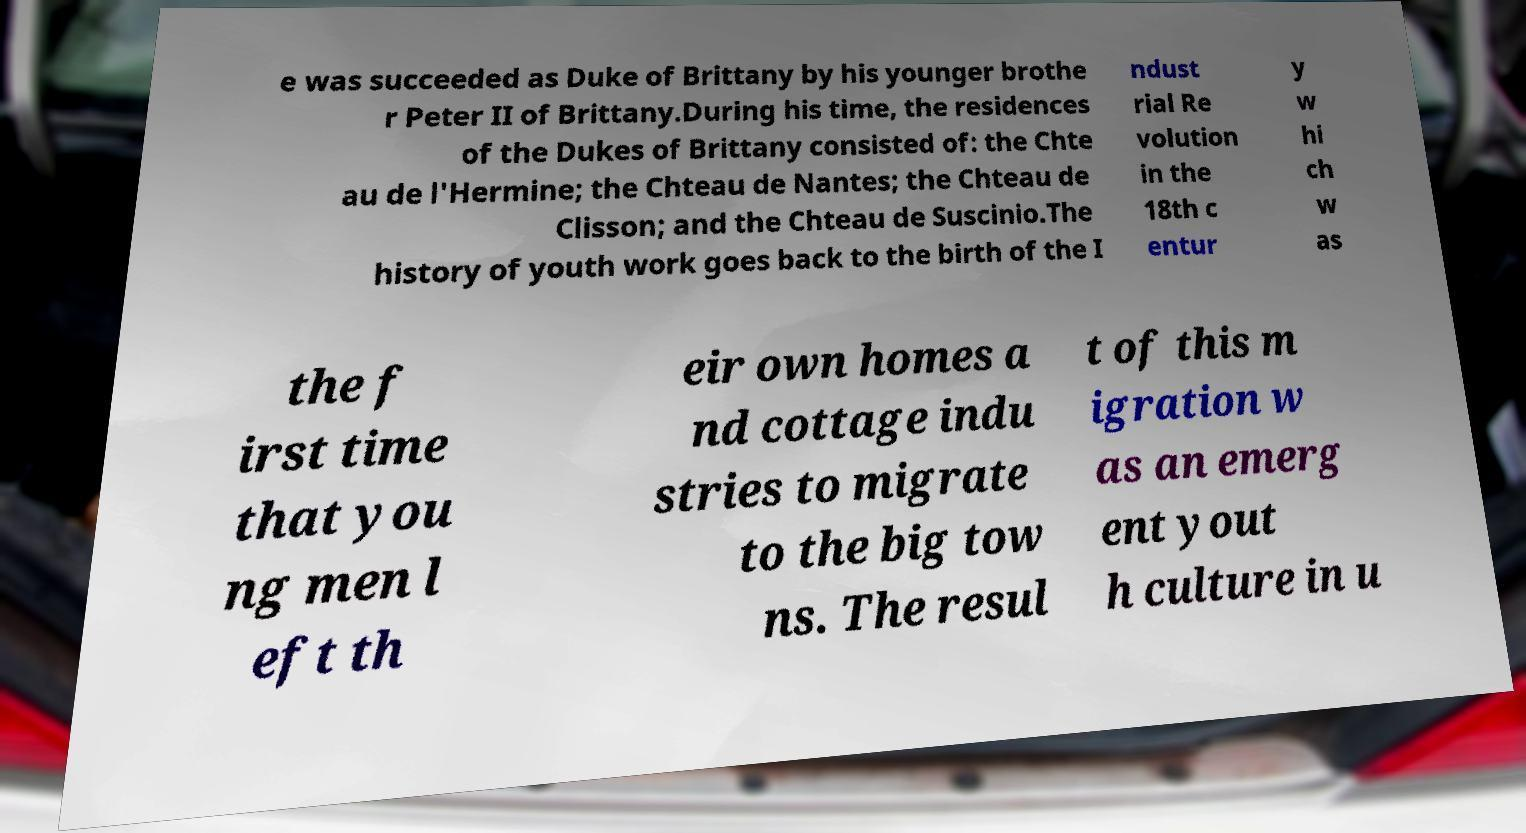Can you accurately transcribe the text from the provided image for me? e was succeeded as Duke of Brittany by his younger brothe r Peter II of Brittany.During his time, the residences of the Dukes of Brittany consisted of: the Chte au de l'Hermine; the Chteau de Nantes; the Chteau de Clisson; and the Chteau de Suscinio.The history of youth work goes back to the birth of the I ndust rial Re volution in the 18th c entur y w hi ch w as the f irst time that you ng men l eft th eir own homes a nd cottage indu stries to migrate to the big tow ns. The resul t of this m igration w as an emerg ent yout h culture in u 